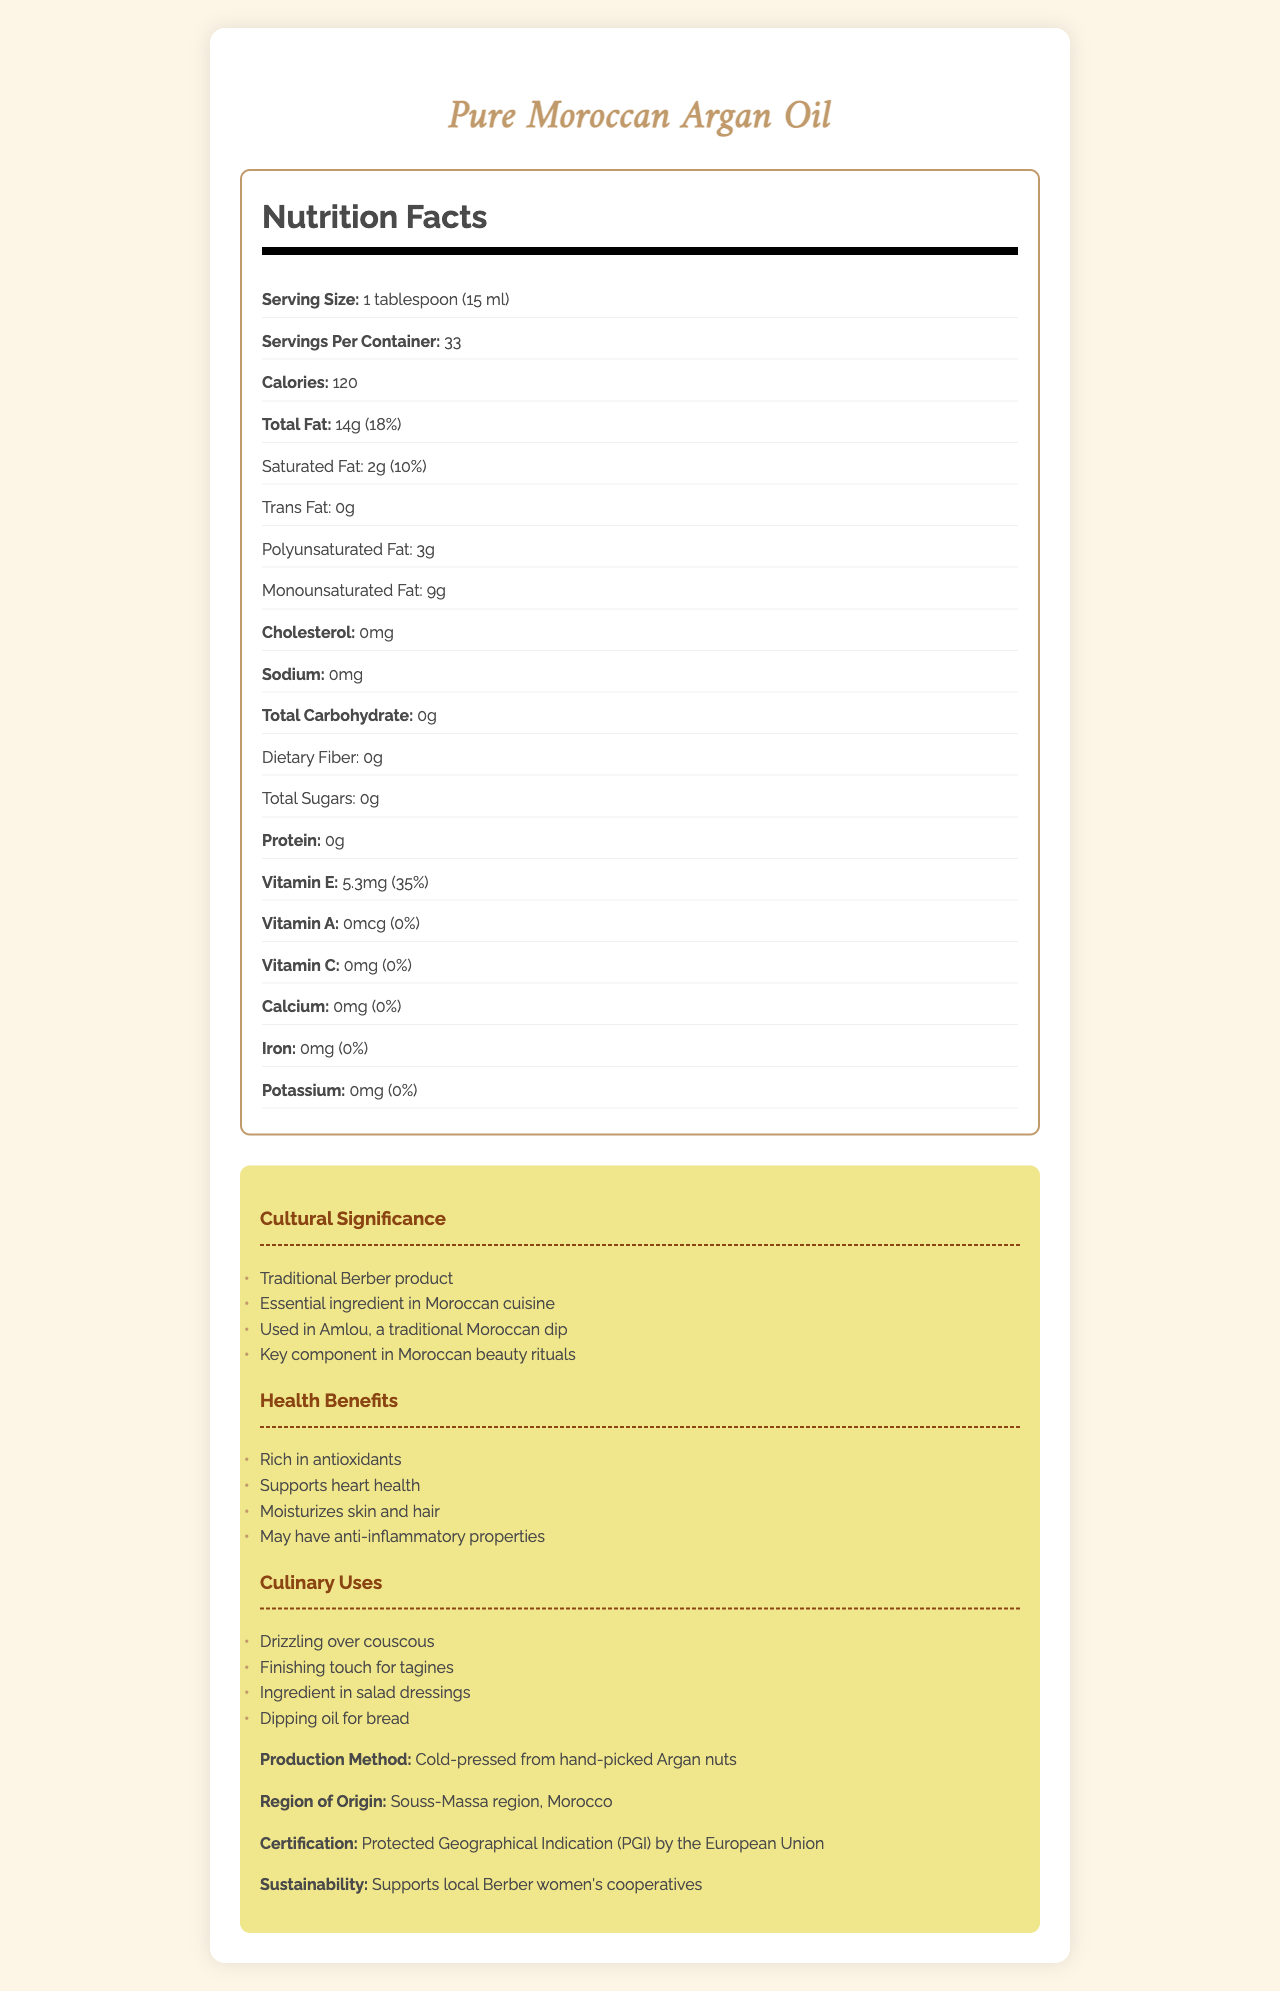what is the serving size of Pure Moroccan Argan Oil? The serving size is clearly mentioned as "1 tablespoon (15 ml)" in the document.
Answer: 1 tablespoon (15 ml) how many calories are in one serving of Pure Moroccan Argan Oil? The document states that there are 120 calories in one serving.
Answer: 120 what is the percentage of daily value for total fat in one serving? The document indicates that the daily value for total fat in one serving is 18%.
Answer: 18% which type of fat is most abundant in Pure Moroccan Argan Oil? The document shows that monounsaturated fat is present in the highest amount (9g) compared to other fats.
Answer: Monounsaturated fat how much Vitamin E does one serving of Pure Moroccan Argan Oil contain? The document specifies that one serving contains 5.3mg of Vitamin E, which is 35% of the daily value.
Answer: 5.3mg how is Pure Moroccan Argan Oil produced? The document states that the oil is "Cold-pressed from hand-picked Argan nuts."
Answer: Cold-pressed from hand-picked Argan nuts in which region of Morocco is Argan Oil produced? The document mentions that the oil originates from the Souss-Massa region of Morocco.
Answer: Souss-Massa region how many servings per container are there? A. 20 B. 25 C. 33 D. 40 The document indicates that there are 33 servings per container.
Answer: C. 33 what is not a health benefit of Pure Moroccan Argan Oil? A. Rich in antioxidants B. High in calcium C. Supports heart health D. Moisturizes skin and hair The document lists health benefits as rich in antioxidants, supporting heart health, and moisturizing skin and hair, but does not mention high in calcium.
Answer: B. High in calcium does the document indicate the presence of sodium in Pure Moroccan Argan Oil? The document states that there is 0mg of sodium in the oil.
Answer: No what is the main purpose of this document? The document includes various sections detailing nutrition information, health benefits, cultural significance, and culinary uses, aiming to inform readers about the aspects of Pure Moroccan Argan Oil.
Answer: To provide detailed nutrition facts and cultural significance of Pure Moroccan Argan Oil who certifies Pure Moroccan Argan Oil? The document mentions that the certification is provided by the Protected Geographical Indication (PGI) by the European Union.
Answer: Protected Geographical Indication (PGI) by the European Union what types of fat does Pure Moroccan Argan Oil contain? The document lists these types of fat: Saturated fat (2g), Trans fat (0g), Polyunsaturated fat (3g), and Monounsaturated fat (9g).
Answer: Saturated fat, Trans fat, Polyunsaturated fat, Monounsaturated fat what is a traditional Moroccan dip that uses Argan Oil? The document highlights that Argan Oil is an essential ingredient in Amlou, a traditional Moroccan dip.
Answer: Amlou how does the production of Argan Oil support local communities? The document states that the production of Argan Oil supports local Berber women's cooperatives.
Answer: Supports local Berber women's cooperatives what ingredient commonly used in Moroccan cuisine is missing in Pure Moroccan Argan Oil? The document provides detailed nutrition facts and cultural context but does not specify what commonly used Moroccan ingredient might be missing.
Answer: Not enough information 